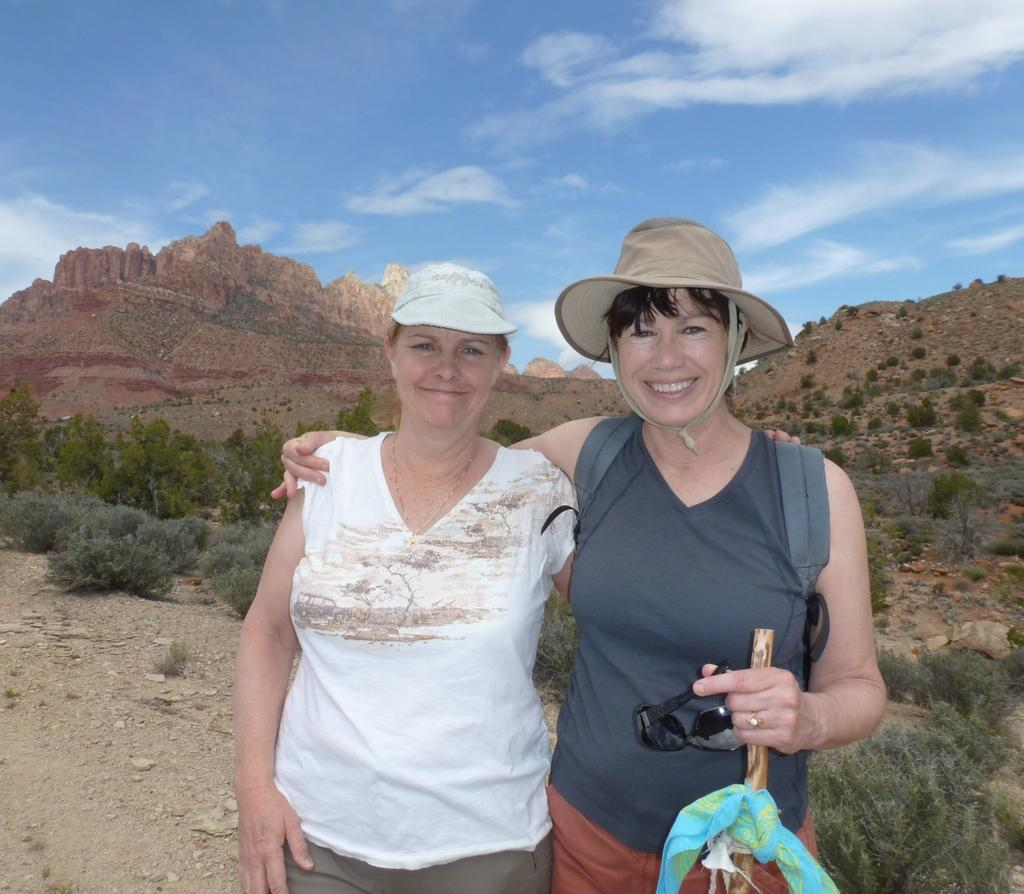How many women are present in the image? There are two women in the image. What are the women holding in the image? The women are holding goggles. What type of natural environment is visible in the image? There are trees and mountains in the image. What is visible in the sky in the image? The sky is visible in the image. Can you see a crown on the head of one of the women in the image? No, there is no crown visible on the head of either woman in the image. What type of screw is being used to hold the building together in the image? There is no building present in the image, so it is not possible to determine what type of screw might be used to hold it together. 